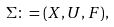<formula> <loc_0><loc_0><loc_500><loc_500>\Sigma \colon = ( X , U , F ) ,</formula> 